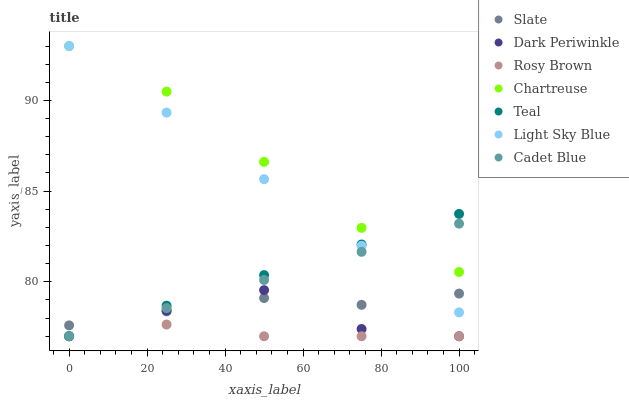Does Rosy Brown have the minimum area under the curve?
Answer yes or no. Yes. Does Chartreuse have the maximum area under the curve?
Answer yes or no. Yes. Does Slate have the minimum area under the curve?
Answer yes or no. No. Does Slate have the maximum area under the curve?
Answer yes or no. No. Is Cadet Blue the smoothest?
Answer yes or no. Yes. Is Dark Periwinkle the roughest?
Answer yes or no. Yes. Is Slate the smoothest?
Answer yes or no. No. Is Slate the roughest?
Answer yes or no. No. Does Cadet Blue have the lowest value?
Answer yes or no. Yes. Does Slate have the lowest value?
Answer yes or no. No. Does Light Sky Blue have the highest value?
Answer yes or no. Yes. Does Slate have the highest value?
Answer yes or no. No. Is Slate less than Chartreuse?
Answer yes or no. Yes. Is Chartreuse greater than Rosy Brown?
Answer yes or no. Yes. Does Cadet Blue intersect Teal?
Answer yes or no. Yes. Is Cadet Blue less than Teal?
Answer yes or no. No. Is Cadet Blue greater than Teal?
Answer yes or no. No. Does Slate intersect Chartreuse?
Answer yes or no. No. 